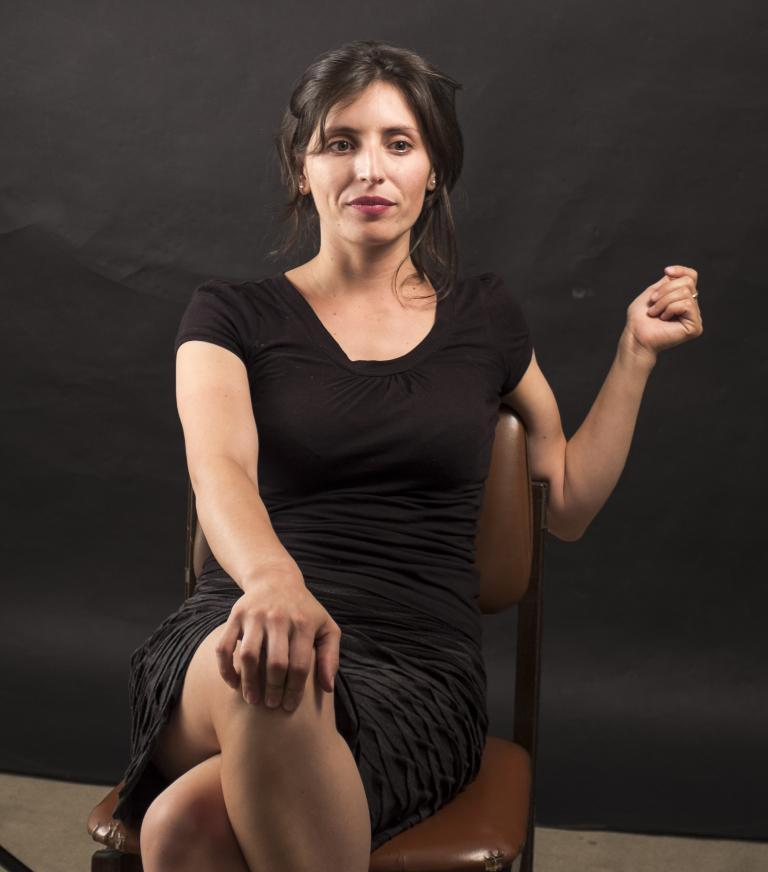What is the woman in the image doing? The woman is sitting in the image. What is the woman wearing? The woman is wearing a black dress. What color is the chair the woman is sitting on? The color of the chair is brown. What color can be seen in the background of the image? There is a black color visible in the background of the image. What historical discovery was made by the queen in the image? There is no queen present in the image, and therefore no historical discovery can be observed. What is the temperature in the room where the woman is sitting in the image? The temperature in the room cannot be determined from the image alone. 